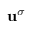<formula> <loc_0><loc_0><loc_500><loc_500>u ^ { \sigma }</formula> 